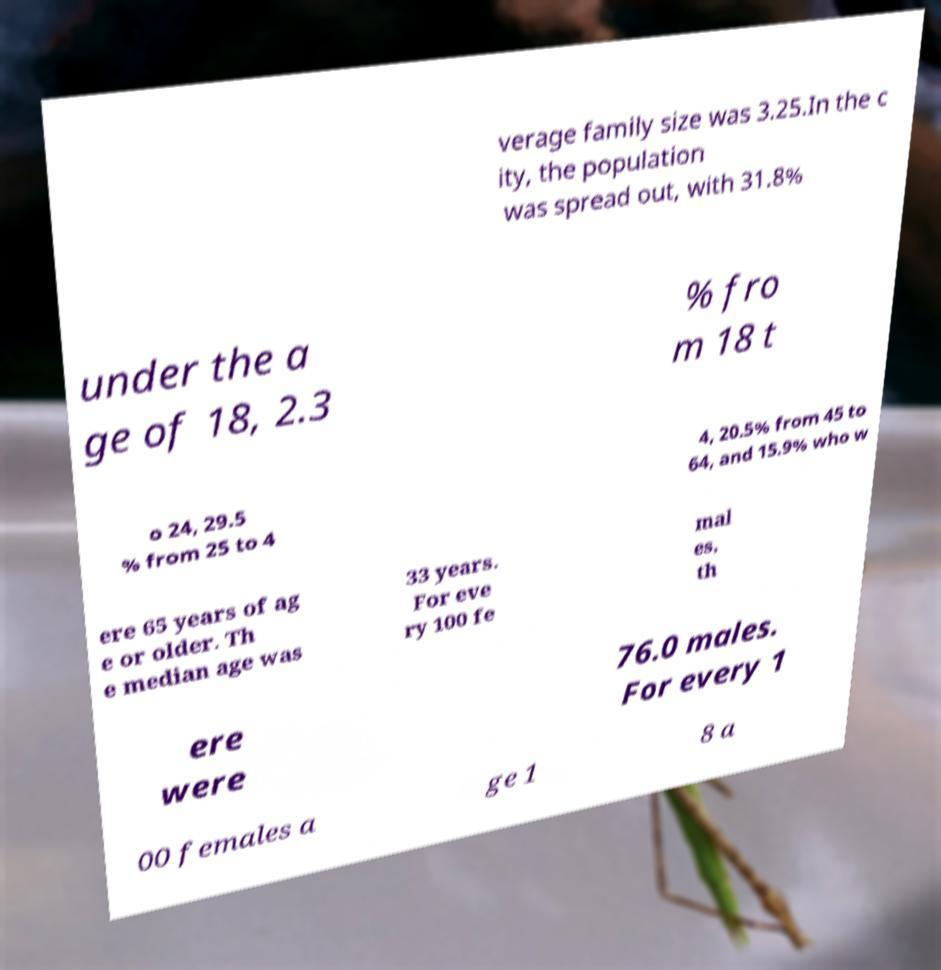Can you read and provide the text displayed in the image?This photo seems to have some interesting text. Can you extract and type it out for me? verage family size was 3.25.In the c ity, the population was spread out, with 31.8% under the a ge of 18, 2.3 % fro m 18 t o 24, 29.5 % from 25 to 4 4, 20.5% from 45 to 64, and 15.9% who w ere 65 years of ag e or older. Th e median age was 33 years. For eve ry 100 fe mal es, th ere were 76.0 males. For every 1 00 females a ge 1 8 a 